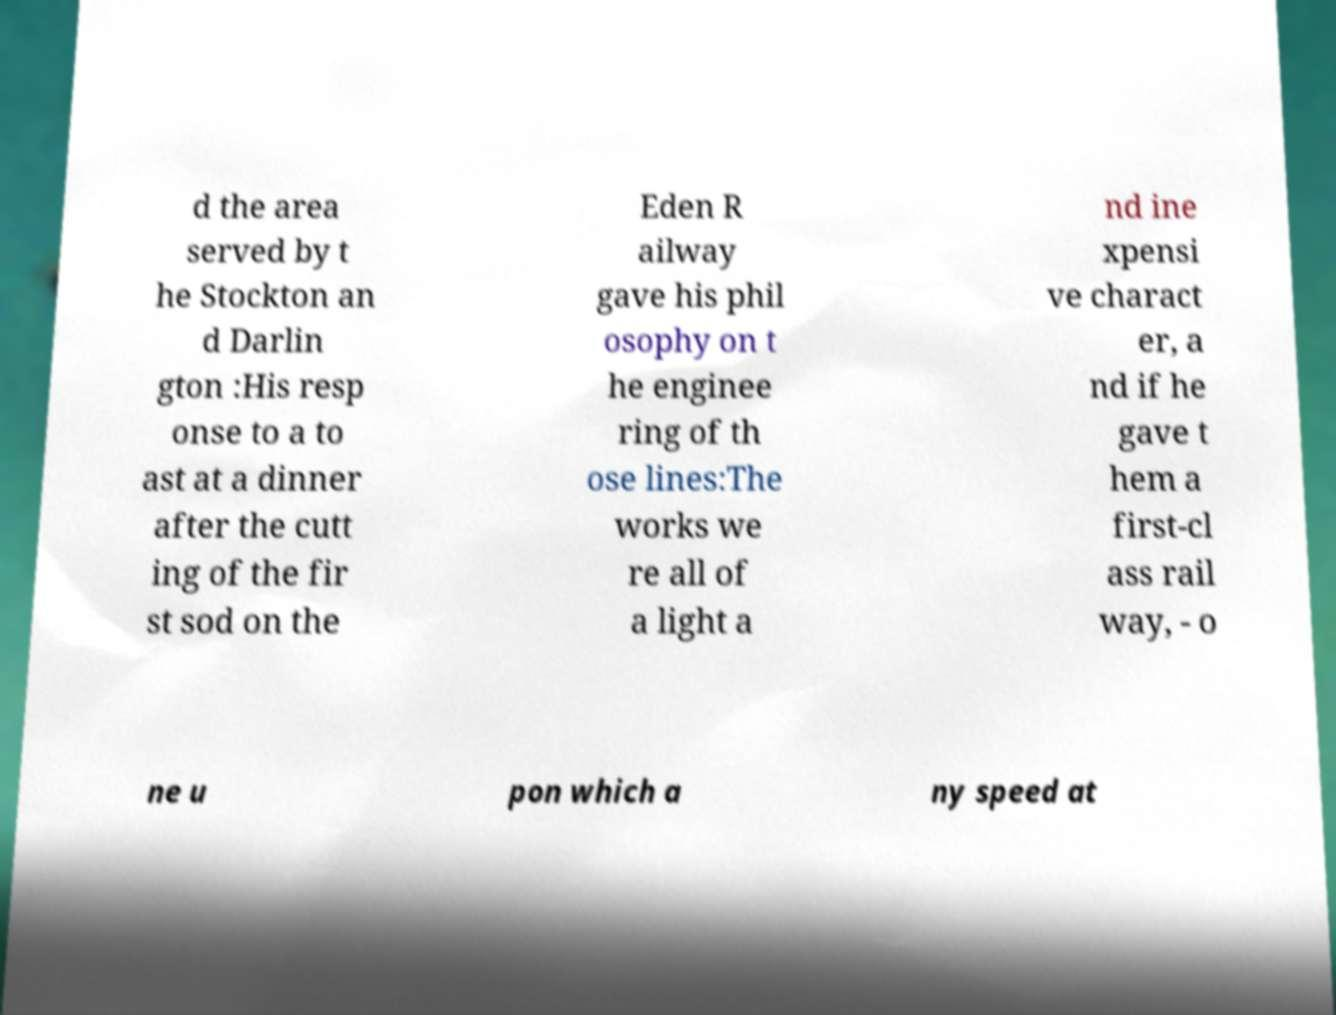I need the written content from this picture converted into text. Can you do that? d the area served by t he Stockton an d Darlin gton :His resp onse to a to ast at a dinner after the cutt ing of the fir st sod on the Eden R ailway gave his phil osophy on t he enginee ring of th ose lines:The works we re all of a light a nd ine xpensi ve charact er, a nd if he gave t hem a first-cl ass rail way, - o ne u pon which a ny speed at 